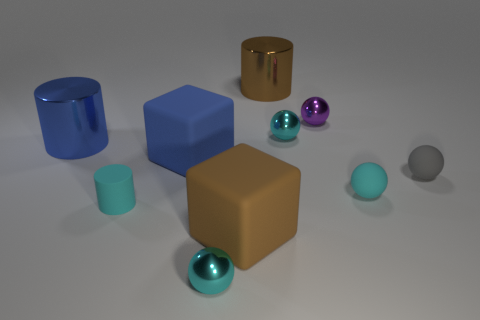Subtract all purple cylinders. How many cyan spheres are left? 3 Subtract all gray balls. How many balls are left? 4 Subtract all small cyan matte balls. How many balls are left? 4 Subtract all yellow spheres. Subtract all yellow cubes. How many spheres are left? 5 Subtract all cylinders. How many objects are left? 7 Add 8 big blocks. How many big blocks are left? 10 Add 5 matte cylinders. How many matte cylinders exist? 6 Subtract 3 cyan spheres. How many objects are left? 7 Subtract all tiny green metal cubes. Subtract all tiny rubber objects. How many objects are left? 7 